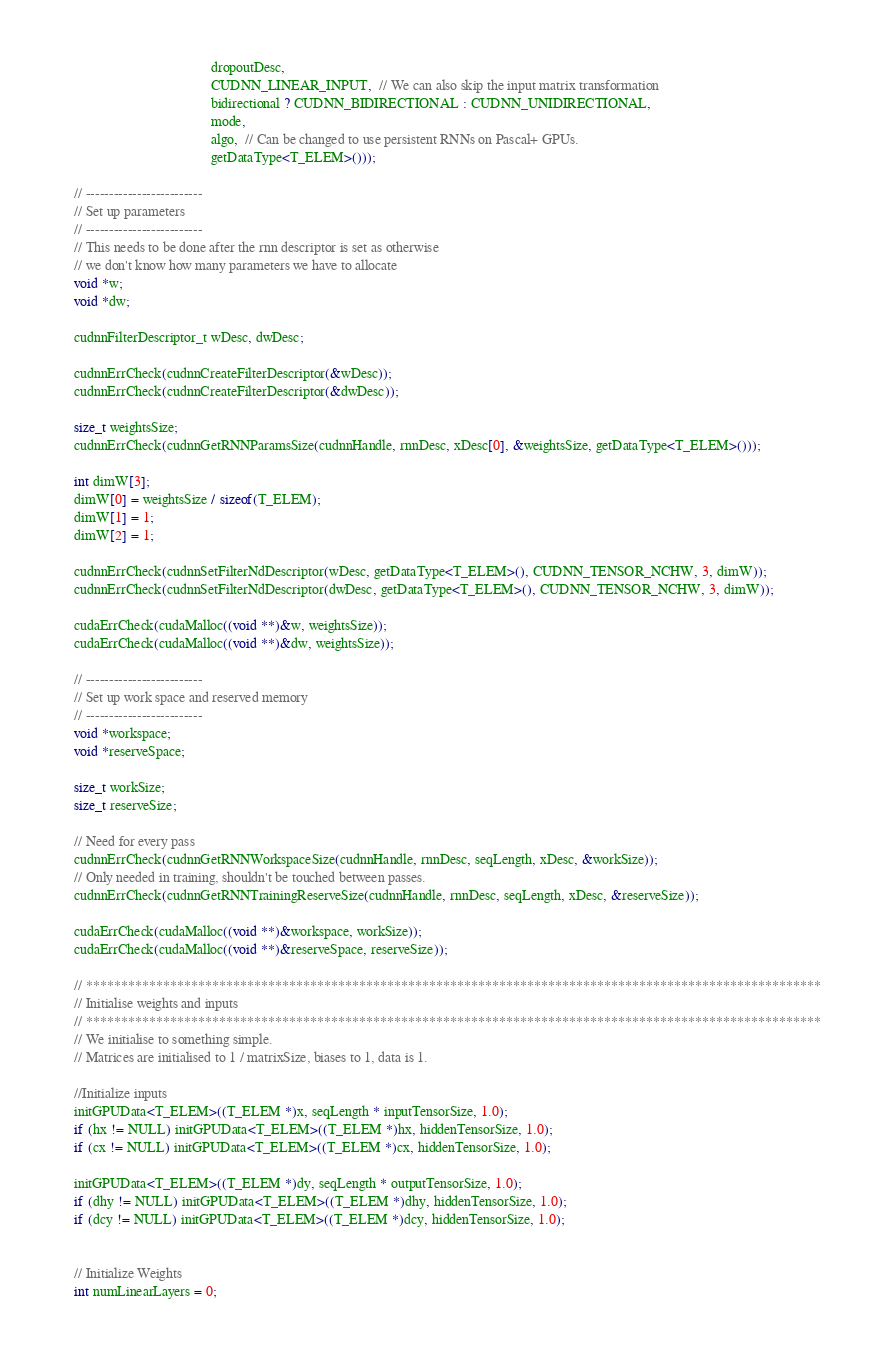Convert code to text. <code><loc_0><loc_0><loc_500><loc_500><_Cuda_>                                           dropoutDesc,
                                           CUDNN_LINEAR_INPUT,  // We can also skip the input matrix transformation
                                           bidirectional ? CUDNN_BIDIRECTIONAL : CUDNN_UNIDIRECTIONAL,
                                           mode,
                                           algo,  // Can be changed to use persistent RNNs on Pascal+ GPUs.
                                           getDataType<T_ELEM>()));

    // -------------------------
    // Set up parameters
    // -------------------------
    // This needs to be done after the rnn descriptor is set as otherwise
    // we don't know how many parameters we have to allocate
    void *w;
    void *dw;

    cudnnFilterDescriptor_t wDesc, dwDesc;

    cudnnErrCheck(cudnnCreateFilterDescriptor(&wDesc));
    cudnnErrCheck(cudnnCreateFilterDescriptor(&dwDesc));

    size_t weightsSize;
    cudnnErrCheck(cudnnGetRNNParamsSize(cudnnHandle, rnnDesc, xDesc[0], &weightsSize, getDataType<T_ELEM>()));

    int dimW[3];
    dimW[0] = weightsSize / sizeof(T_ELEM);
    dimW[1] = 1;
    dimW[2] = 1;

    cudnnErrCheck(cudnnSetFilterNdDescriptor(wDesc, getDataType<T_ELEM>(), CUDNN_TENSOR_NCHW, 3, dimW));
    cudnnErrCheck(cudnnSetFilterNdDescriptor(dwDesc, getDataType<T_ELEM>(), CUDNN_TENSOR_NCHW, 3, dimW));

    cudaErrCheck(cudaMalloc((void **)&w, weightsSize));
    cudaErrCheck(cudaMalloc((void **)&dw, weightsSize));

    // -------------------------
    // Set up work space and reserved memory
    // -------------------------
    void *workspace;
    void *reserveSpace;

    size_t workSize;
    size_t reserveSize;

    // Need for every pass
    cudnnErrCheck(cudnnGetRNNWorkspaceSize(cudnnHandle, rnnDesc, seqLength, xDesc, &workSize));
    // Only needed in training, shouldn't be touched between passes.
    cudnnErrCheck(cudnnGetRNNTrainingReserveSize(cudnnHandle, rnnDesc, seqLength, xDesc, &reserveSize));

    cudaErrCheck(cudaMalloc((void **)&workspace, workSize));
    cudaErrCheck(cudaMalloc((void **)&reserveSpace, reserveSize));

    // *********************************************************************************************************
    // Initialise weights and inputs
    // *********************************************************************************************************
    // We initialise to something simple.
    // Matrices are initialised to 1 / matrixSize, biases to 1, data is 1.

    //Initialize inputs
    initGPUData<T_ELEM>((T_ELEM *)x, seqLength * inputTensorSize, 1.0);
    if (hx != NULL) initGPUData<T_ELEM>((T_ELEM *)hx, hiddenTensorSize, 1.0);
    if (cx != NULL) initGPUData<T_ELEM>((T_ELEM *)cx, hiddenTensorSize, 1.0);

    initGPUData<T_ELEM>((T_ELEM *)dy, seqLength * outputTensorSize, 1.0);
    if (dhy != NULL) initGPUData<T_ELEM>((T_ELEM *)dhy, hiddenTensorSize, 1.0);
    if (dcy != NULL) initGPUData<T_ELEM>((T_ELEM *)dcy, hiddenTensorSize, 1.0);


    // Initialize Weights
    int numLinearLayers = 0;</code> 